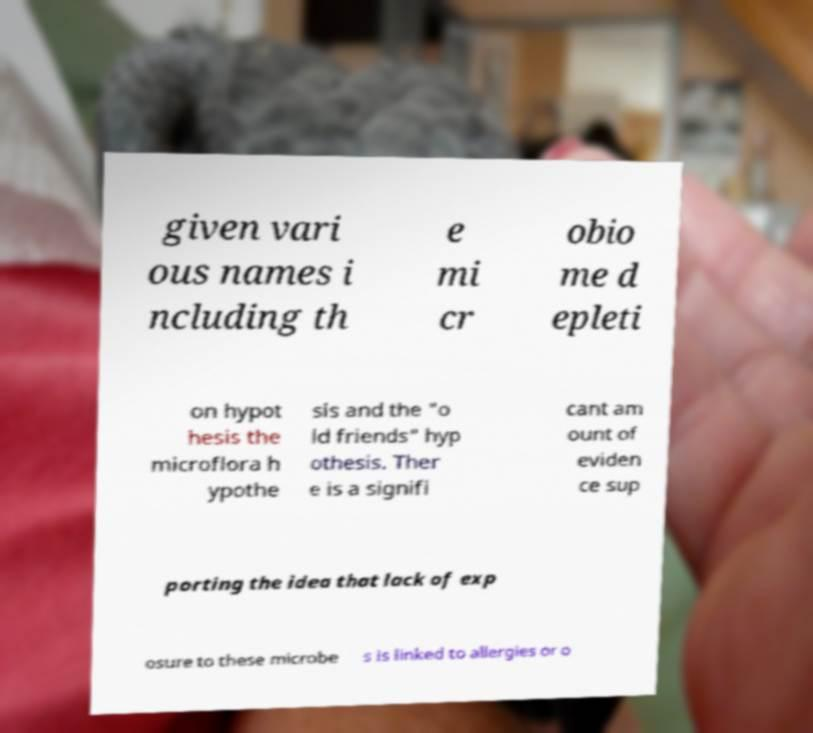Please identify and transcribe the text found in this image. given vari ous names i ncluding th e mi cr obio me d epleti on hypot hesis the microflora h ypothe sis and the "o ld friends" hyp othesis. Ther e is a signifi cant am ount of eviden ce sup porting the idea that lack of exp osure to these microbe s is linked to allergies or o 